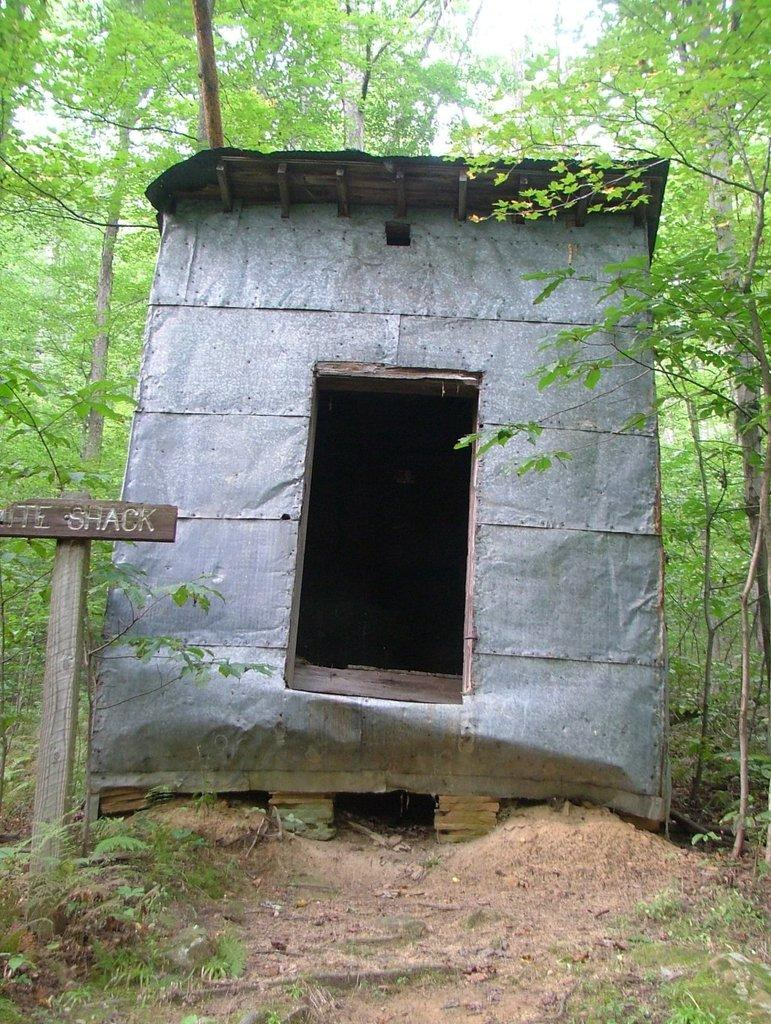What animal can be seen in the image? There is a shark in the image. What object is also present in the image? There is a board in the image. What type of environment is depicted in the image? Grass and trees are present in the image, suggesting a natural setting. What is written on the board? There is writing on the board. How many bears can be seen wearing gloves in the image? There are no bears or gloves present in the image. What type of detail can be seen on the shark's fin in the image? There is no detail mentioned on the shark's fin in the provided facts, and the image does not show any additional details beyond what is stated. 